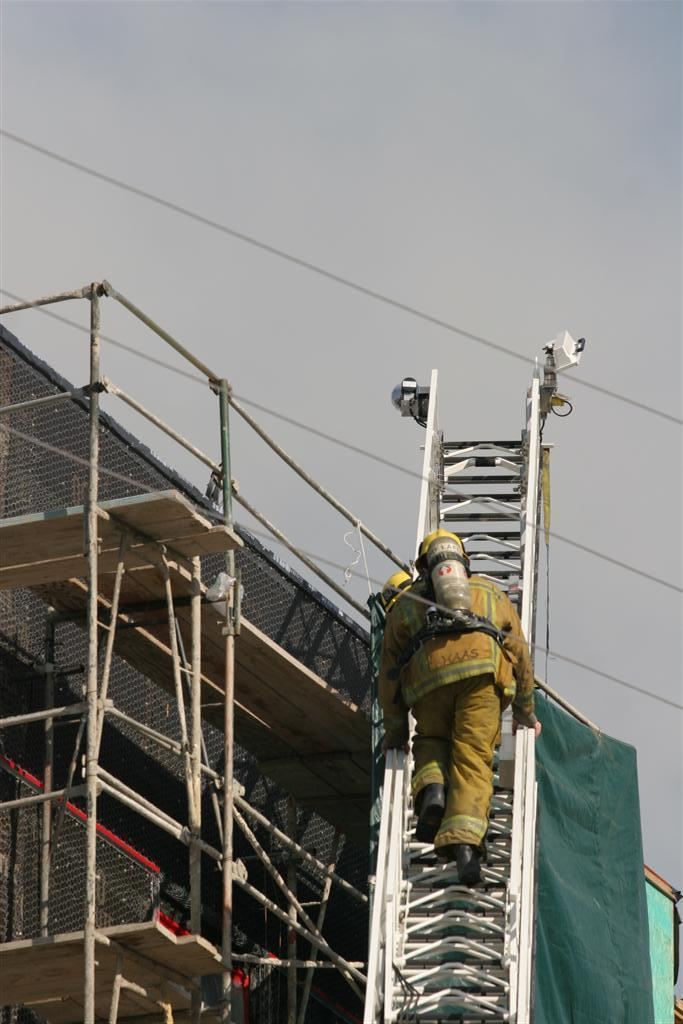What is the person in the image doing? The person is on a ladder in the image. What can be seen in the sky in the image? The sky is clear in the image. What else is visible in the image besides the person on the ladder? Electrical wires are visible in the image. What is located on the left side of the image? There appears to be a construction building on the left side of the image. Where is the zoo located in the image? There is no zoo present in the image. Can you see any fairies flying around the person on the ladder? There are no fairies present in the image. 